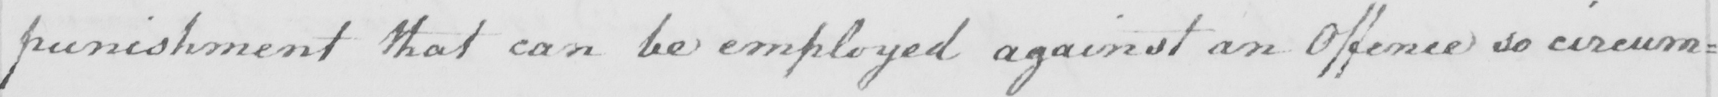Can you read and transcribe this handwriting? punishment that can be employed against an Offence so circum= 